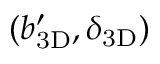Convert formula to latex. <formula><loc_0><loc_0><loc_500><loc_500>( { b _ { 3 D } ^ { \prime } } , { \delta _ { 3 D } } )</formula> 